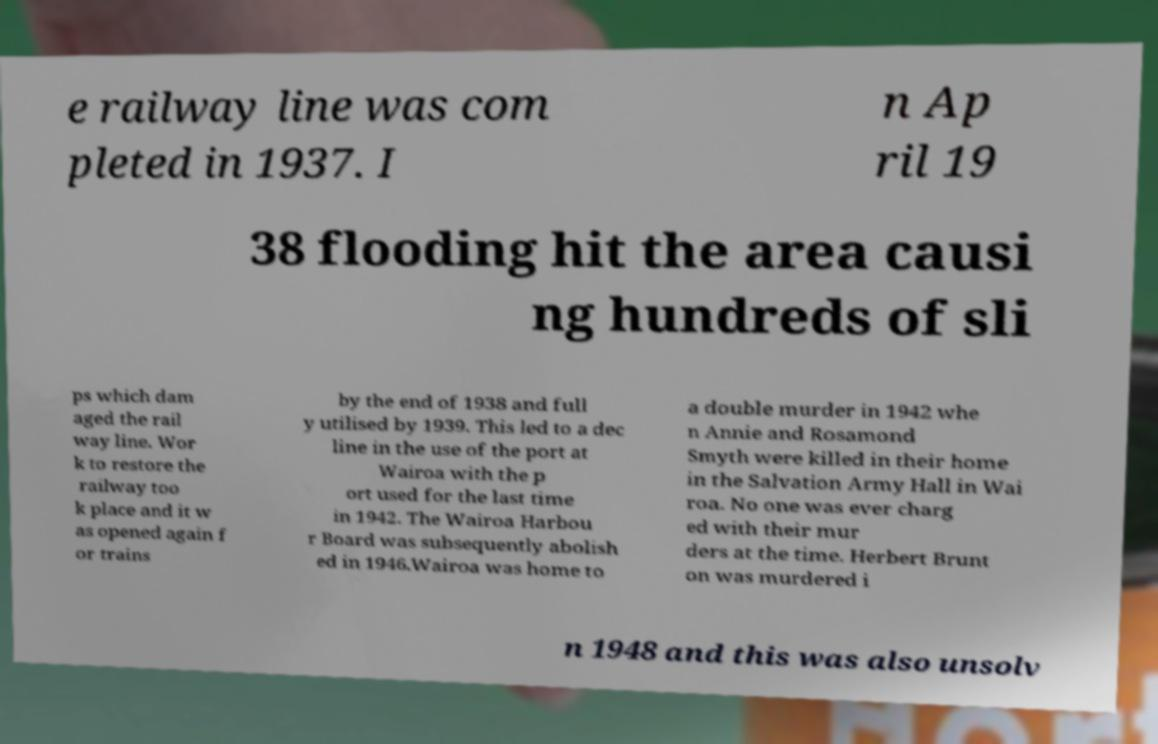For documentation purposes, I need the text within this image transcribed. Could you provide that? e railway line was com pleted in 1937. I n Ap ril 19 38 flooding hit the area causi ng hundreds of sli ps which dam aged the rail way line. Wor k to restore the railway too k place and it w as opened again f or trains by the end of 1938 and full y utilised by 1939. This led to a dec line in the use of the port at Wairoa with the p ort used for the last time in 1942. The Wairoa Harbou r Board was subsequently abolish ed in 1946.Wairoa was home to a double murder in 1942 whe n Annie and Rosamond Smyth were killed in their home in the Salvation Army Hall in Wai roa. No one was ever charg ed with their mur ders at the time. Herbert Brunt on was murdered i n 1948 and this was also unsolv 